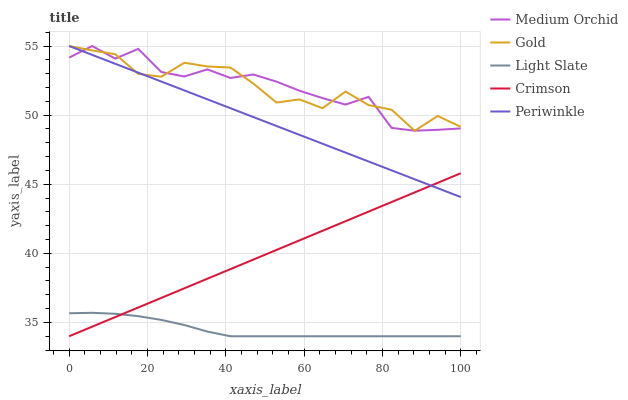Does Light Slate have the minimum area under the curve?
Answer yes or no. Yes. Does Medium Orchid have the maximum area under the curve?
Answer yes or no. Yes. Does Crimson have the minimum area under the curve?
Answer yes or no. No. Does Crimson have the maximum area under the curve?
Answer yes or no. No. Is Periwinkle the smoothest?
Answer yes or no. Yes. Is Gold the roughest?
Answer yes or no. Yes. Is Crimson the smoothest?
Answer yes or no. No. Is Crimson the roughest?
Answer yes or no. No. Does Light Slate have the lowest value?
Answer yes or no. Yes. Does Medium Orchid have the lowest value?
Answer yes or no. No. Does Gold have the highest value?
Answer yes or no. Yes. Does Crimson have the highest value?
Answer yes or no. No. Is Light Slate less than Medium Orchid?
Answer yes or no. Yes. Is Periwinkle greater than Light Slate?
Answer yes or no. Yes. Does Periwinkle intersect Gold?
Answer yes or no. Yes. Is Periwinkle less than Gold?
Answer yes or no. No. Is Periwinkle greater than Gold?
Answer yes or no. No. Does Light Slate intersect Medium Orchid?
Answer yes or no. No. 